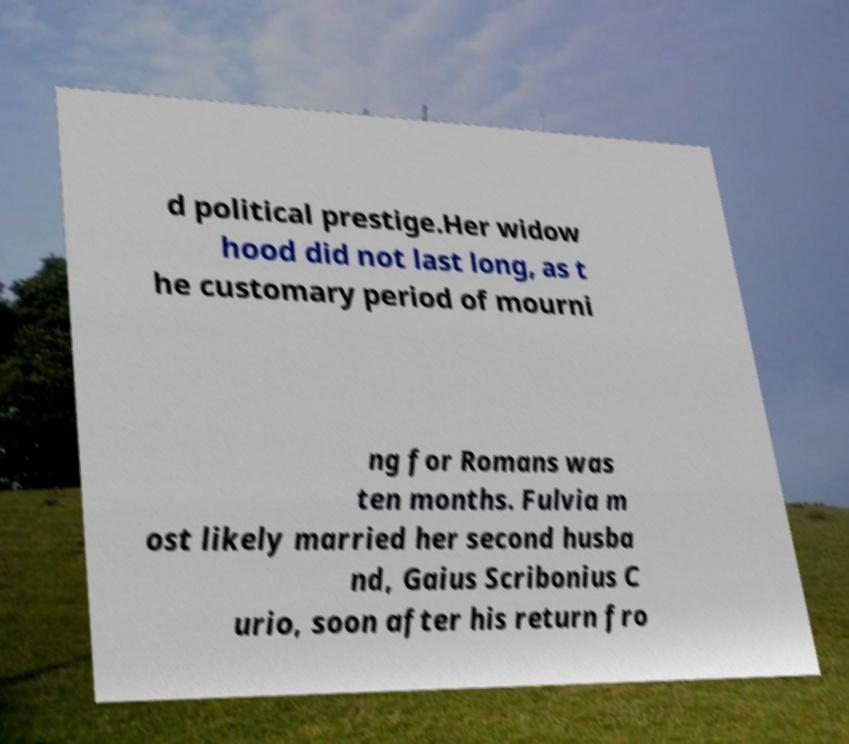Could you assist in decoding the text presented in this image and type it out clearly? d political prestige.Her widow hood did not last long, as t he customary period of mourni ng for Romans was ten months. Fulvia m ost likely married her second husba nd, Gaius Scribonius C urio, soon after his return fro 